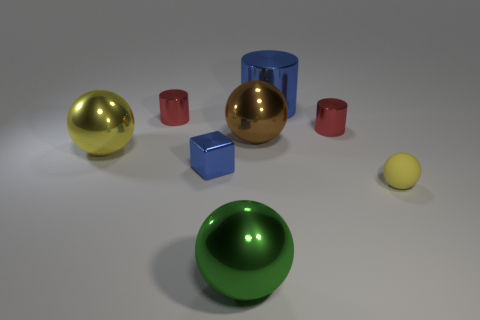Subtract 1 spheres. How many spheres are left? 3 Add 1 small brown matte blocks. How many objects exist? 9 Subtract all cylinders. How many objects are left? 5 Subtract 0 green cubes. How many objects are left? 8 Subtract all large balls. Subtract all large yellow metallic balls. How many objects are left? 4 Add 1 shiny blocks. How many shiny blocks are left? 2 Add 6 tiny shiny blocks. How many tiny shiny blocks exist? 7 